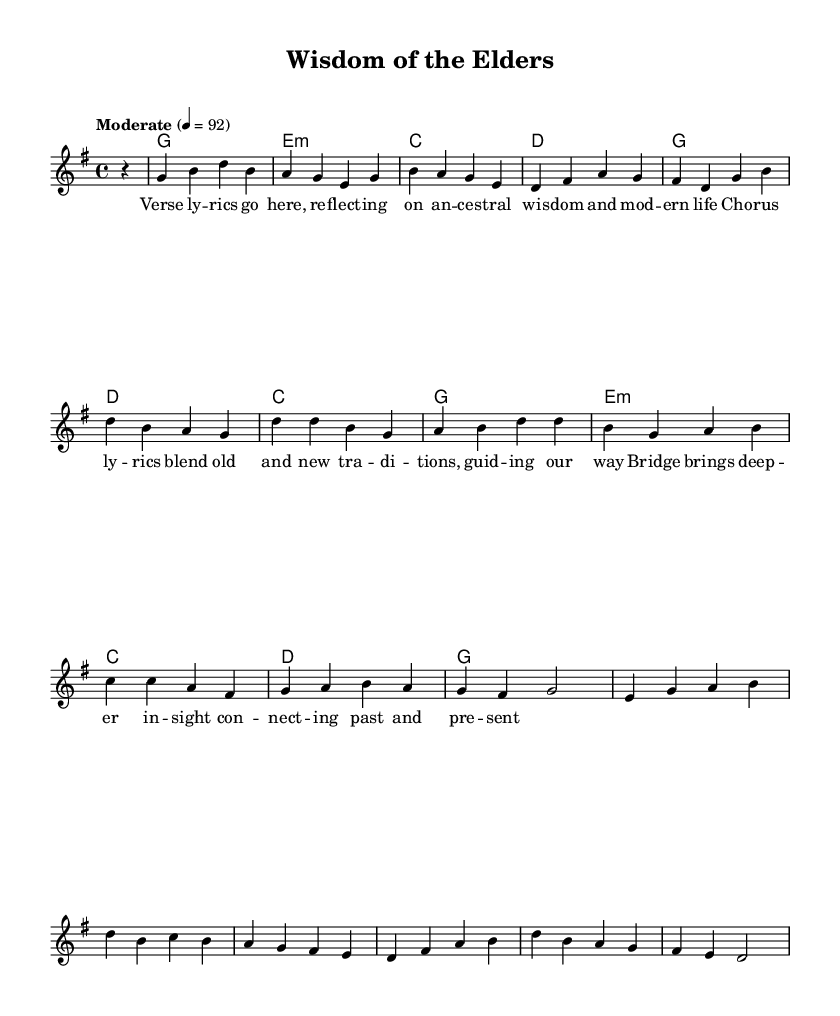What is the key signature of this music? The key signature is G major, which has one sharp (F#), indicated at the beginning of the staff.
Answer: G major What is the time signature of this music? The time signature is 4/4, which means there are four beats in each measure, indicated by the "4/4" notation at the beginning of the score.
Answer: 4/4 What is the tempo marking of this piece? The tempo is marked as "Moderate" at 4 = 92, which indicates a moderate pace at which the music should be played.
Answer: Moderate How many measures are in the melody? By counting each distinct vertical line separating the notes, there are a total of 16 measures in the melody.
Answer: 16 What instrument is this score intended for? This score is intended for a voice or melody instrument, as indicated by the use of a single staff for the lead melody line.
Answer: Voice What do the lyrics in the chorus signify in this song? The lyrics in the chorus express a blending of old and new traditions, highlighting the balance between ancestral wisdom and modern life.
Answer: Blending of traditions What is the role of the bridge in this composition? The bridge serves to bring deeper insight and connects the past with the present, offering a contrasting section that adds depth to the narrative of the song.
Answer: Connects past and present 